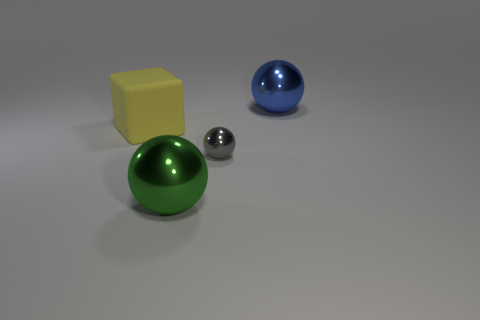What could be the possible materials of these objects? The green and blue spheres appear to be made of a polished plastic or enamel, reflecting light with a slight glossiness. The metallic sphere looks like polished stainless steel, given its reflective and smooth surface. The yellow cube has a matte finish that could suggest a non-reflective plastic or painted wood.  If these objects were part of a larger set, what patterns or design rules might they follow? Considering their geometric simplicity and distinct colors, these objects could be part of an educational set, perhaps for teaching shapes and colors. The design rule they would follow might emphasize clear visual distinctions among shapes, consistent color application, and varied textures to engage sensory learning. 